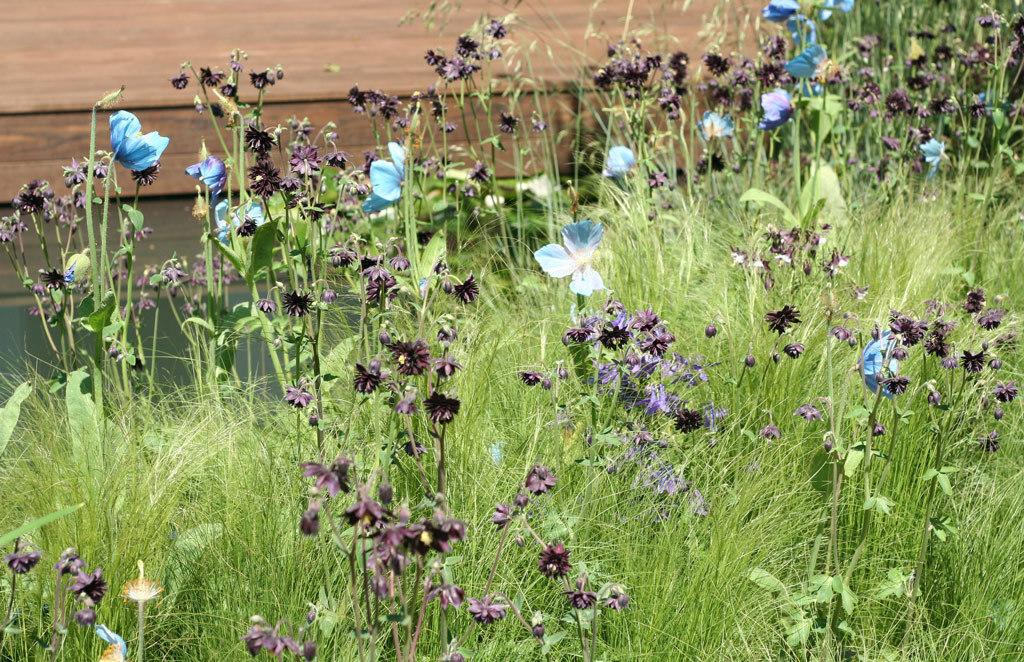What types of vegetation can be seen in the foreground of the image? There are plants, grass, and flowers in the foreground of the image. What is the primary feature of the foreground? The primary feature of the foreground is the vegetation, including plants, grass, and flowers. What can be seen in the background of the image? There is a wall in the background of the image. How does the comfort of the plants affect the growth of the flowers in the image? The image does not provide information about the comfort of the plants or its effect on the growth of the flowers. 